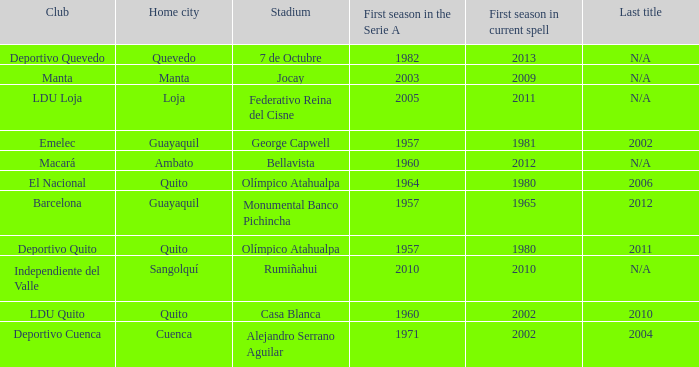Name the most for first season in the serie a for 7 de octubre 1982.0. Could you parse the entire table? {'header': ['Club', 'Home city', 'Stadium', 'First season in the Serie A', 'First season in current spell', 'Last title'], 'rows': [['Deportivo Quevedo', 'Quevedo', '7 de Octubre', '1982', '2013', 'N/A'], ['Manta', 'Manta', 'Jocay', '2003', '2009', 'N/A'], ['LDU Loja', 'Loja', 'Federativo Reina del Cisne', '2005', '2011', 'N/A'], ['Emelec', 'Guayaquil', 'George Capwell', '1957', '1981', '2002'], ['Macará', 'Ambato', 'Bellavista', '1960', '2012', 'N/A'], ['El Nacional', 'Quito', 'Olímpico Atahualpa', '1964', '1980', '2006'], ['Barcelona', 'Guayaquil', 'Monumental Banco Pichincha', '1957', '1965', '2012'], ['Deportivo Quito', 'Quito', 'Olímpico Atahualpa', '1957', '1980', '2011'], ['Independiente del Valle', 'Sangolquí', 'Rumiñahui', '2010', '2010', 'N/A'], ['LDU Quito', 'Quito', 'Casa Blanca', '1960', '2002', '2010'], ['Deportivo Cuenca', 'Cuenca', 'Alejandro Serrano Aguilar', '1971', '2002', '2004']]} 